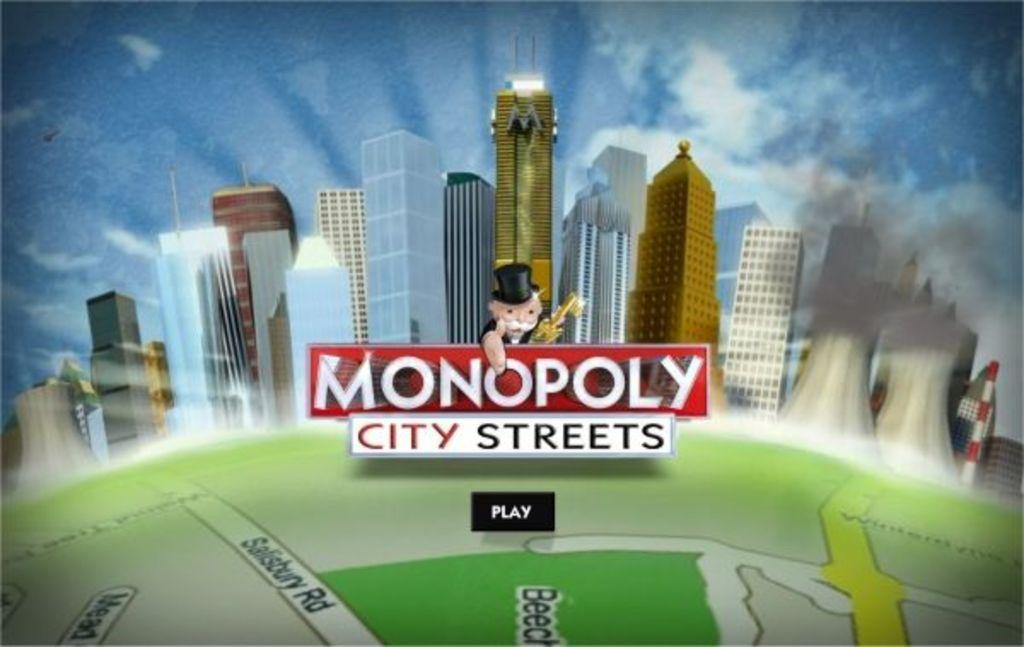<image>
Share a concise interpretation of the image provided. A screen shows a Monopoly logo and a tab that says play. 